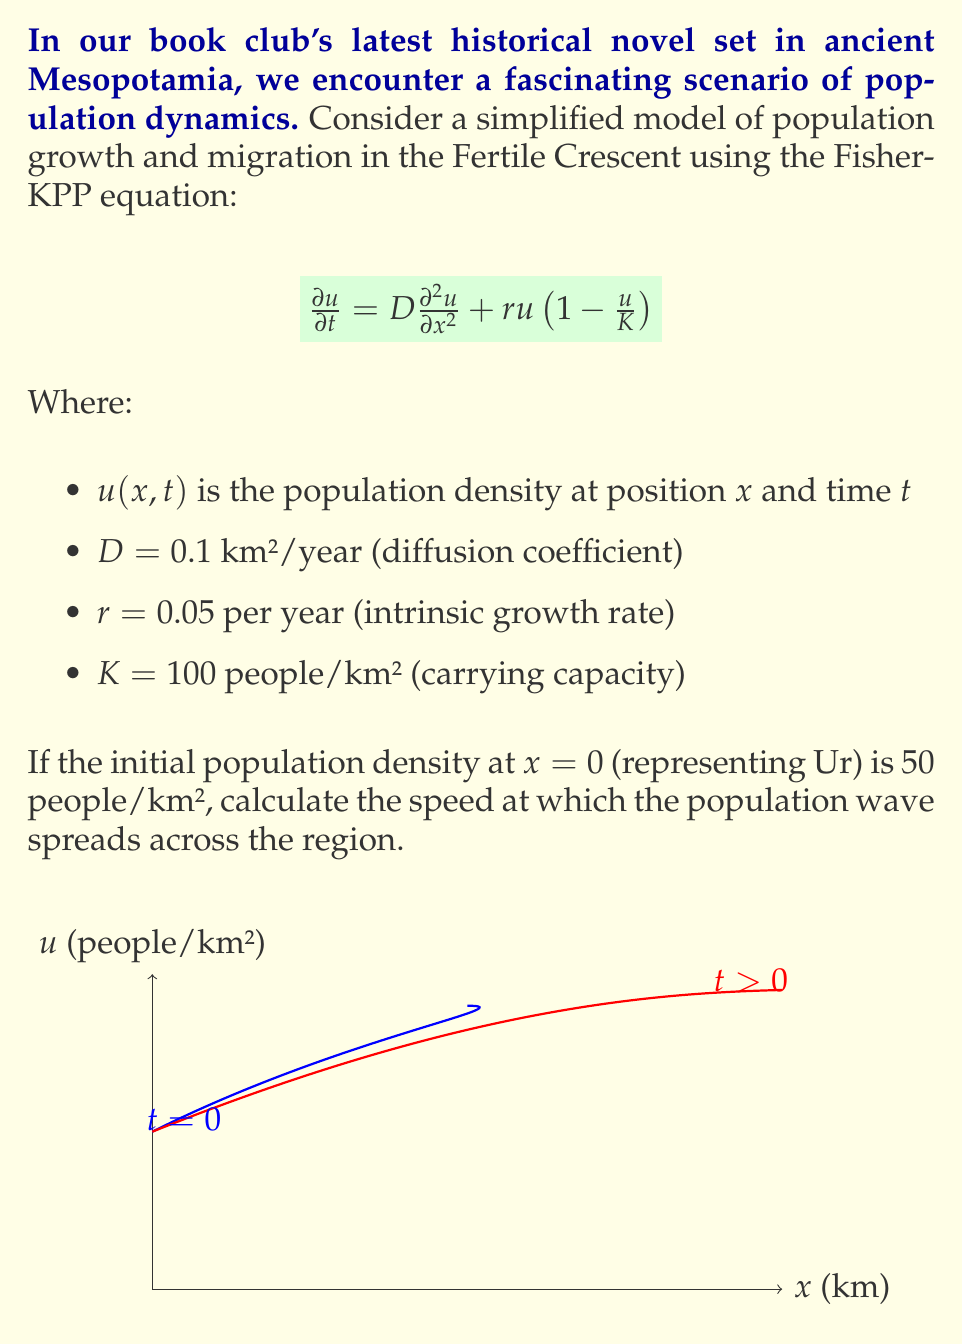Show me your answer to this math problem. To solve this problem, we'll use the formula for the wave speed of the Fisher-KPP equation:

1) The wave speed $c$ for the Fisher-KPP equation is given by:

   $$c = 2\sqrt{rD}$$

2) We're given:
   - $D = 0.1$ km²/year
   - $r = 0.05$ per year

3) Let's substitute these values into the equation:

   $$c = 2\sqrt{(0.05)(0.1)}$$

4) Simplify under the square root:

   $$c = 2\sqrt{0.005}$$

5) Calculate the square root:

   $$c = 2(0.0707)$$

6) Multiply:

   $$c = 0.1414$$ km/year

This means the population wave spreads at a speed of approximately 0.1414 km per year across the Fertile Crescent region.

Note: The initial population density and carrying capacity don't affect the wave speed in this model, but they influence the shape of the wave.
Answer: 0.1414 km/year 